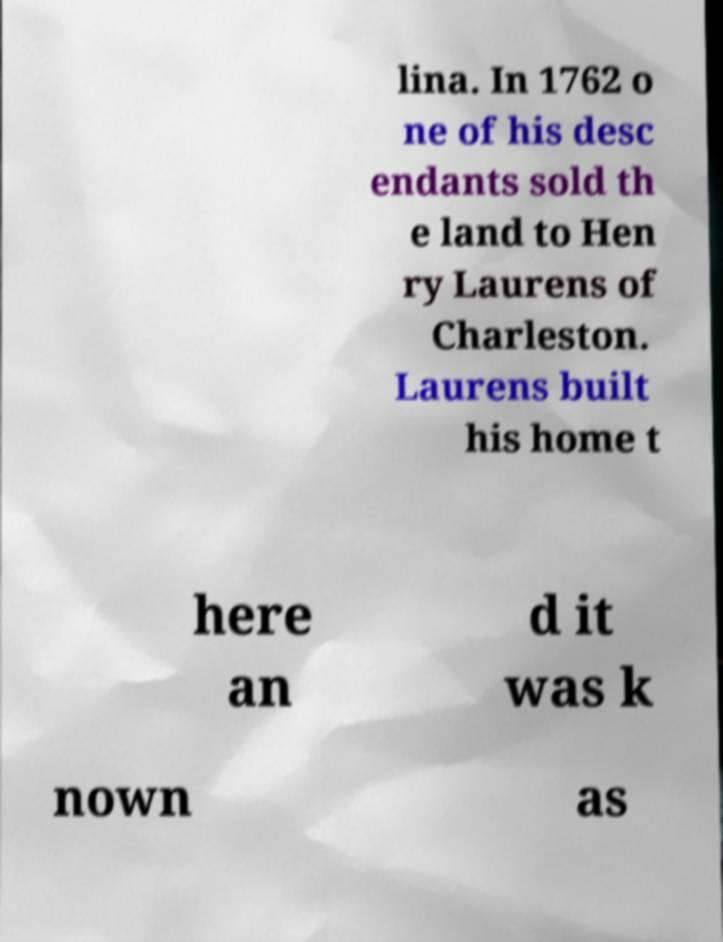I need the written content from this picture converted into text. Can you do that? lina. In 1762 o ne of his desc endants sold th e land to Hen ry Laurens of Charleston. Laurens built his home t here an d it was k nown as 